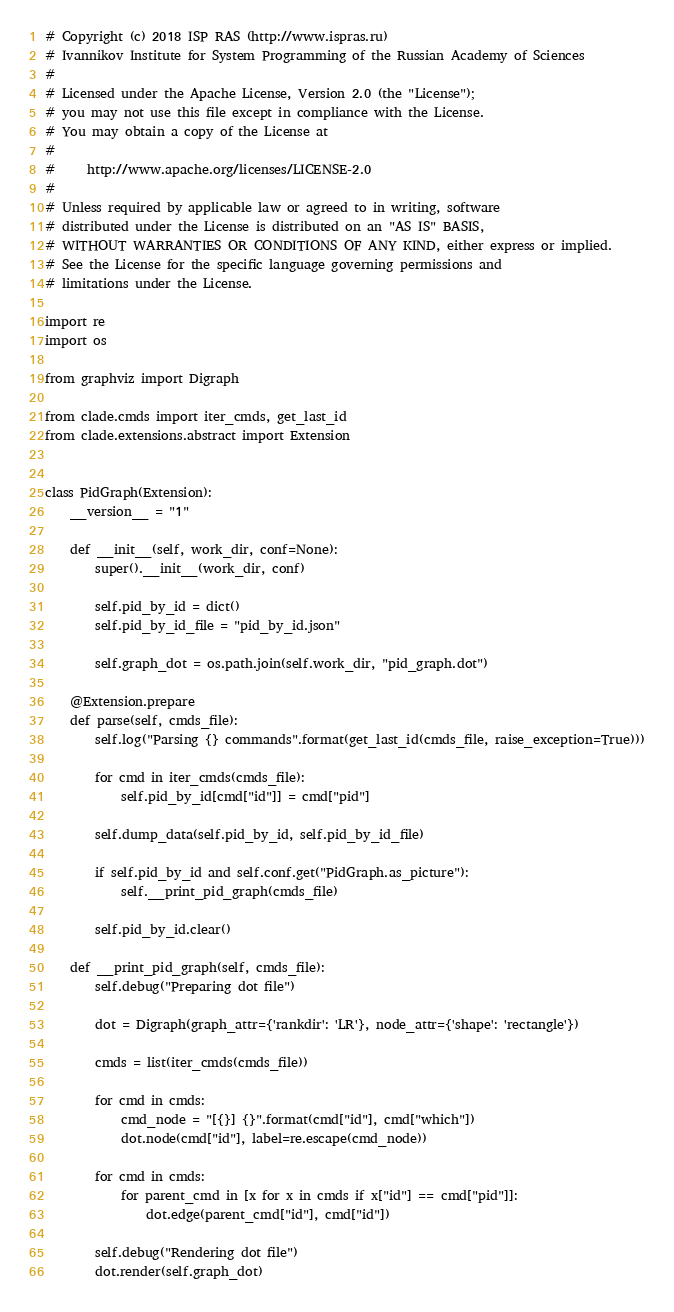<code> <loc_0><loc_0><loc_500><loc_500><_Python_># Copyright (c) 2018 ISP RAS (http://www.ispras.ru)
# Ivannikov Institute for System Programming of the Russian Academy of Sciences
#
# Licensed under the Apache License, Version 2.0 (the "License");
# you may not use this file except in compliance with the License.
# You may obtain a copy of the License at
#
#     http://www.apache.org/licenses/LICENSE-2.0
#
# Unless required by applicable law or agreed to in writing, software
# distributed under the License is distributed on an "AS IS" BASIS,
# WITHOUT WARRANTIES OR CONDITIONS OF ANY KIND, either express or implied.
# See the License for the specific language governing permissions and
# limitations under the License.

import re
import os

from graphviz import Digraph

from clade.cmds import iter_cmds, get_last_id
from clade.extensions.abstract import Extension


class PidGraph(Extension):
    __version__ = "1"

    def __init__(self, work_dir, conf=None):
        super().__init__(work_dir, conf)

        self.pid_by_id = dict()
        self.pid_by_id_file = "pid_by_id.json"

        self.graph_dot = os.path.join(self.work_dir, "pid_graph.dot")

    @Extension.prepare
    def parse(self, cmds_file):
        self.log("Parsing {} commands".format(get_last_id(cmds_file, raise_exception=True)))

        for cmd in iter_cmds(cmds_file):
            self.pid_by_id[cmd["id"]] = cmd["pid"]

        self.dump_data(self.pid_by_id, self.pid_by_id_file)

        if self.pid_by_id and self.conf.get("PidGraph.as_picture"):
            self.__print_pid_graph(cmds_file)

        self.pid_by_id.clear()

    def __print_pid_graph(self, cmds_file):
        self.debug("Preparing dot file")

        dot = Digraph(graph_attr={'rankdir': 'LR'}, node_attr={'shape': 'rectangle'})

        cmds = list(iter_cmds(cmds_file))

        for cmd in cmds:
            cmd_node = "[{}] {}".format(cmd["id"], cmd["which"])
            dot.node(cmd["id"], label=re.escape(cmd_node))

        for cmd in cmds:
            for parent_cmd in [x for x in cmds if x["id"] == cmd["pid"]]:
                dot.edge(parent_cmd["id"], cmd["id"])

        self.debug("Rendering dot file")
        dot.render(self.graph_dot)
</code> 